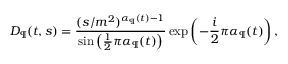<formula> <loc_0><loc_0><loc_500><loc_500>D _ { \P } ( t , s ) = \frac { ( s / m ^ { 2 } ) ^ { \alpha _ { \P } ( t ) - 1 } } { \sin \left ( \frac { 1 } { 2 } \pi \alpha _ { \P } ( t ) \right ) } \exp \left ( - \frac { i } { 2 } \pi \alpha _ { \P } ( t ) \right ) ,</formula> 